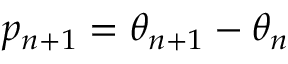Convert formula to latex. <formula><loc_0><loc_0><loc_500><loc_500>p _ { n + 1 } = \theta _ { n + 1 } - \theta _ { n }</formula> 